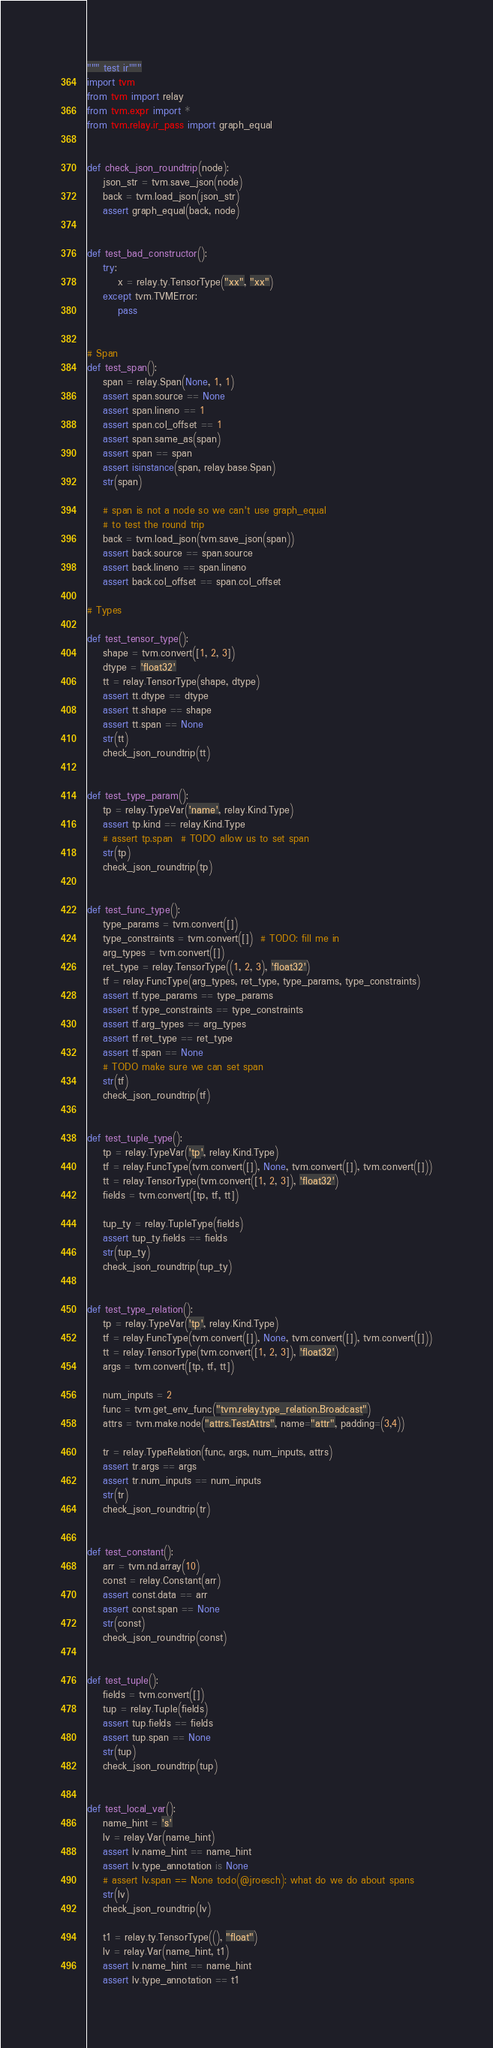<code> <loc_0><loc_0><loc_500><loc_500><_Python_>""" test ir"""
import tvm
from tvm import relay
from tvm.expr import *
from tvm.relay.ir_pass import graph_equal


def check_json_roundtrip(node):
    json_str = tvm.save_json(node)
    back = tvm.load_json(json_str)
    assert graph_equal(back, node)


def test_bad_constructor():
    try:
        x = relay.ty.TensorType("xx", "xx")
    except tvm.TVMError:
        pass


# Span
def test_span():
    span = relay.Span(None, 1, 1)
    assert span.source == None
    assert span.lineno == 1
    assert span.col_offset == 1
    assert span.same_as(span)
    assert span == span
    assert isinstance(span, relay.base.Span)
    str(span)

    # span is not a node so we can't use graph_equal
    # to test the round trip
    back = tvm.load_json(tvm.save_json(span))
    assert back.source == span.source
    assert back.lineno == span.lineno
    assert back.col_offset == span.col_offset

# Types

def test_tensor_type():
    shape = tvm.convert([1, 2, 3])
    dtype = 'float32'
    tt = relay.TensorType(shape, dtype)
    assert tt.dtype == dtype
    assert tt.shape == shape
    assert tt.span == None
    str(tt)
    check_json_roundtrip(tt)


def test_type_param():
    tp = relay.TypeVar('name', relay.Kind.Type)
    assert tp.kind == relay.Kind.Type
    # assert tp.span  # TODO allow us to set span
    str(tp)
    check_json_roundtrip(tp)


def test_func_type():
    type_params = tvm.convert([])
    type_constraints = tvm.convert([])  # TODO: fill me in
    arg_types = tvm.convert([])
    ret_type = relay.TensorType((1, 2, 3), 'float32')
    tf = relay.FuncType(arg_types, ret_type, type_params, type_constraints)
    assert tf.type_params == type_params
    assert tf.type_constraints == type_constraints
    assert tf.arg_types == arg_types
    assert tf.ret_type == ret_type
    assert tf.span == None
    # TODO make sure we can set span
    str(tf)
    check_json_roundtrip(tf)


def test_tuple_type():
    tp = relay.TypeVar('tp', relay.Kind.Type)
    tf = relay.FuncType(tvm.convert([]), None, tvm.convert([]), tvm.convert([]))
    tt = relay.TensorType(tvm.convert([1, 2, 3]), 'float32')
    fields = tvm.convert([tp, tf, tt])

    tup_ty = relay.TupleType(fields)
    assert tup_ty.fields == fields
    str(tup_ty)
    check_json_roundtrip(tup_ty)


def test_type_relation():
    tp = relay.TypeVar('tp', relay.Kind.Type)
    tf = relay.FuncType(tvm.convert([]), None, tvm.convert([]), tvm.convert([]))
    tt = relay.TensorType(tvm.convert([1, 2, 3]), 'float32')
    args = tvm.convert([tp, tf, tt])

    num_inputs = 2
    func = tvm.get_env_func("tvm.relay.type_relation.Broadcast")
    attrs = tvm.make.node("attrs.TestAttrs", name="attr", padding=(3,4))

    tr = relay.TypeRelation(func, args, num_inputs, attrs)
    assert tr.args == args
    assert tr.num_inputs == num_inputs
    str(tr)
    check_json_roundtrip(tr)


def test_constant():
    arr = tvm.nd.array(10)
    const = relay.Constant(arr)
    assert const.data == arr
    assert const.span == None
    str(const)
    check_json_roundtrip(const)


def test_tuple():
    fields = tvm.convert([])
    tup = relay.Tuple(fields)
    assert tup.fields == fields
    assert tup.span == None
    str(tup)
    check_json_roundtrip(tup)


def test_local_var():
    name_hint = 's'
    lv = relay.Var(name_hint)
    assert lv.name_hint == name_hint
    assert lv.type_annotation is None
    # assert lv.span == None todo(@jroesch): what do we do about spans
    str(lv)
    check_json_roundtrip(lv)

    t1 = relay.ty.TensorType((), "float")
    lv = relay.Var(name_hint, t1)
    assert lv.name_hint == name_hint
    assert lv.type_annotation == t1

</code> 